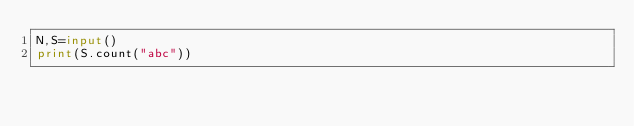Convert code to text. <code><loc_0><loc_0><loc_500><loc_500><_Python_>N,S=input()
print(S.count("abc"))</code> 